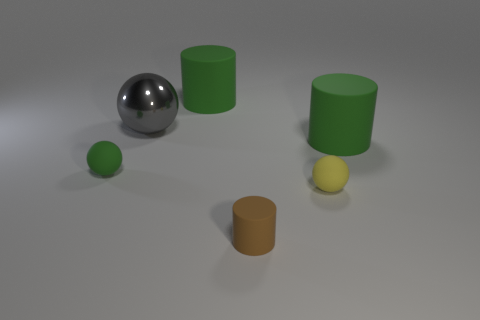How many objects are either large green things or rubber balls that are behind the small yellow rubber thing?
Your answer should be compact. 3. There is a green rubber cylinder behind the gray sphere; does it have the same size as the small cylinder?
Your answer should be compact. No. There is a big green object that is to the left of the brown rubber cylinder; what material is it?
Give a very brief answer. Rubber. Is the number of green matte spheres that are in front of the small green thing the same as the number of big gray objects that are behind the big gray metallic object?
Give a very brief answer. Yes. What color is the big metallic object that is the same shape as the tiny green rubber thing?
Your response must be concise. Gray. Is there any other thing that has the same color as the metal sphere?
Ensure brevity in your answer.  No. What number of metal things are either brown things or spheres?
Your answer should be compact. 1. Does the shiny object have the same color as the tiny matte cylinder?
Give a very brief answer. No. Is the number of metal balls to the right of the large metal object greater than the number of purple objects?
Provide a succinct answer. No. How many other things are the same material as the big gray ball?
Provide a succinct answer. 0. 